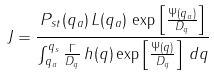Convert formula to latex. <formula><loc_0><loc_0><loc_500><loc_500>J = \frac { P _ { s t } ( q _ { a } ) \, L ( q _ { a } ) \, \exp \left [ \frac { \Psi ( q _ { a } ) } { D _ { q } } \right ] } { \int _ { q _ { a } } ^ { q _ { s } } \frac { \Gamma } { D _ { q } } \, h ( q ) \exp \left [ \frac { \Psi ( q ) } { D _ { q } } \right ] \, d q }</formula> 